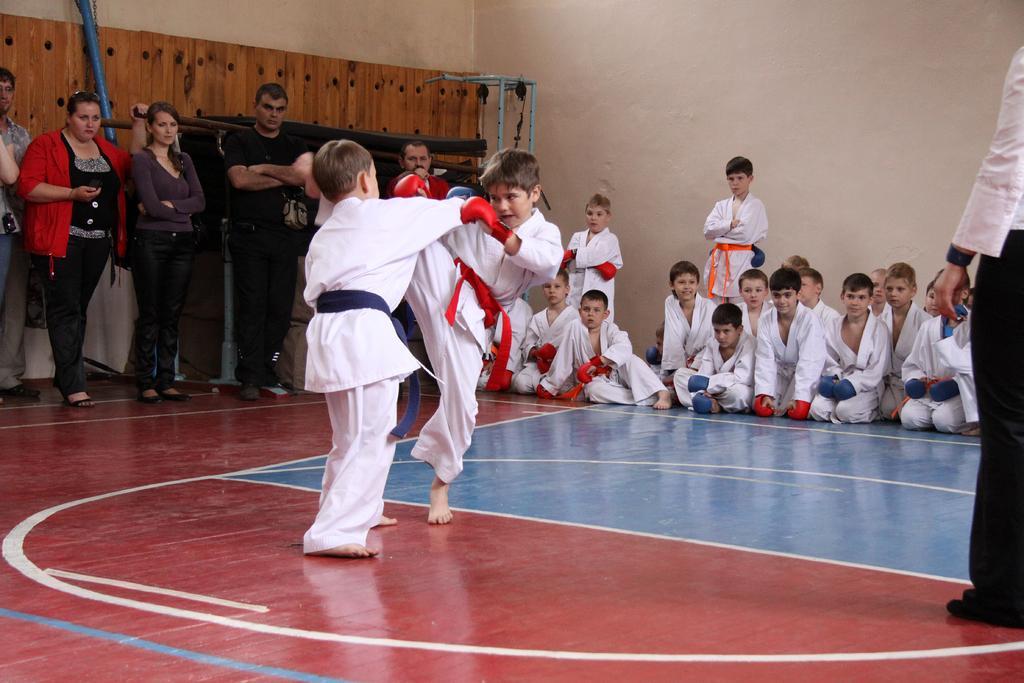How would you summarize this image in a sentence or two? In the image we can see there are many children's wearing clothes and gloves. There are even people standing and watching these two children's. This is a floor, wooden sheet, pole and a wall. 